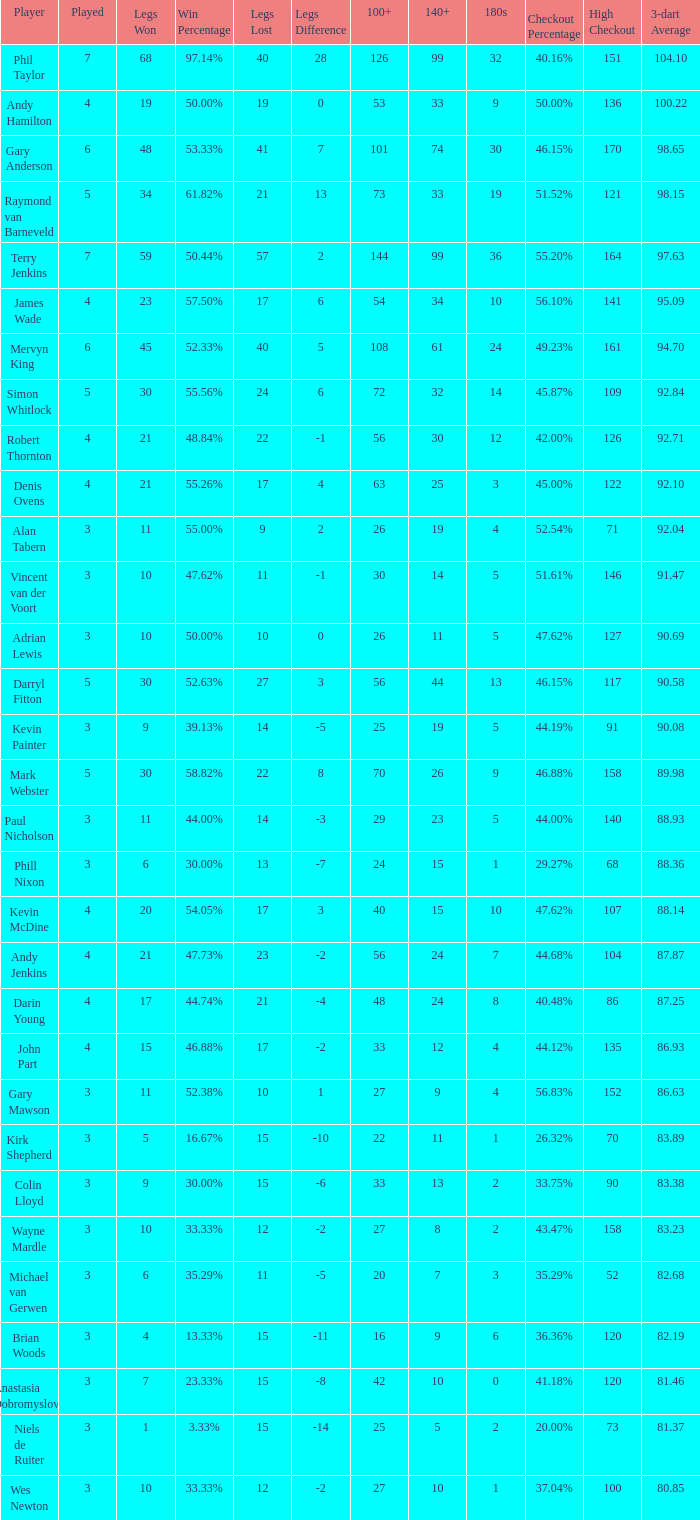Help me parse the entirety of this table. {'header': ['Player', 'Played', 'Legs Won', 'Win Percentage', 'Legs Lost', 'Legs Difference', '100+', '140+', '180s', 'Checkout Percentage', 'High Checkout', '3-dart Average'], 'rows': [['Phil Taylor', '7', '68', '97.14%', '40', '28', '126', '99', '32', '40.16%', '151', '104.10'], ['Andy Hamilton', '4', '19', '50.00%', '19', '0', '53', '33', '9', '50.00%', '136', '100.22'], ['Gary Anderson', '6', '48', '53.33%', '41', '7', '101', '74', '30', '46.15%', '170', '98.65'], ['Raymond van Barneveld', '5', '34', '61.82%', '21', '13', '73', '33', '19', '51.52%', '121', '98.15'], ['Terry Jenkins', '7', '59', '50.44%', '57', '2', '144', '99', '36', '55.20%', '164', '97.63'], ['James Wade', '4', '23', '57.50%', '17', '6', '54', '34', '10', '56.10%', '141', '95.09'], ['Mervyn King', '6', '45', '52.33%', '40', '5', '108', '61', '24', '49.23%', '161', '94.70'], ['Simon Whitlock', '5', '30', '55.56%', '24', '6', '72', '32', '14', '45.87%', '109', '92.84'], ['Robert Thornton', '4', '21', '48.84%', '22', '-1', '56', '30', '12', '42.00%', '126', '92.71'], ['Denis Ovens', '4', '21', '55.26%', '17', '4', '63', '25', '3', '45.00%', '122', '92.10'], ['Alan Tabern', '3', '11', '55.00%', '9', '2', '26', '19', '4', '52.54%', '71', '92.04'], ['Vincent van der Voort', '3', '10', '47.62%', '11', '-1', '30', '14', '5', '51.61%', '146', '91.47'], ['Adrian Lewis', '3', '10', '50.00%', '10', '0', '26', '11', '5', '47.62%', '127', '90.69'], ['Darryl Fitton', '5', '30', '52.63%', '27', '3', '56', '44', '13', '46.15%', '117', '90.58'], ['Kevin Painter', '3', '9', '39.13%', '14', '-5', '25', '19', '5', '44.19%', '91', '90.08'], ['Mark Webster', '5', '30', '58.82%', '22', '8', '70', '26', '9', '46.88%', '158', '89.98'], ['Paul Nicholson', '3', '11', '44.00%', '14', '-3', '29', '23', '5', '44.00%', '140', '88.93'], ['Phill Nixon', '3', '6', '30.00%', '13', '-7', '24', '15', '1', '29.27%', '68', '88.36'], ['Kevin McDine', '4', '20', '54.05%', '17', '3', '40', '15', '10', '47.62%', '107', '88.14'], ['Andy Jenkins', '4', '21', '47.73%', '23', '-2', '56', '24', '7', '44.68%', '104', '87.87'], ['Darin Young', '4', '17', '44.74%', '21', '-4', '48', '24', '8', '40.48%', '86', '87.25'], ['John Part', '4', '15', '46.88%', '17', '-2', '33', '12', '4', '44.12%', '135', '86.93'], ['Gary Mawson', '3', '11', '52.38%', '10', '1', '27', '9', '4', '56.83%', '152', '86.63'], ['Kirk Shepherd', '3', '5', '16.67%', '15', '-10', '22', '11', '1', '26.32%', '70', '83.89'], ['Colin Lloyd', '3', '9', '30.00%', '15', '-6', '33', '13', '2', '33.75%', '90', '83.38'], ['Wayne Mardle', '3', '10', '33.33%', '12', '-2', '27', '8', '2', '43.47%', '158', '83.23'], ['Michael van Gerwen', '3', '6', '35.29%', '11', '-5', '20', '7', '3', '35.29%', '52', '82.68'], ['Brian Woods', '3', '4', '13.33%', '15', '-11', '16', '9', '6', '36.36%', '120', '82.19'], ['Anastasia Dobromyslova', '3', '7', '23.33%', '15', '-8', '42', '10', '0', '41.18%', '120', '81.46'], ['Niels de Ruiter', '3', '1', '3.33%', '15', '-14', '25', '5', '2', '20.00%', '73', '81.37'], ['Wes Newton', '3', '10', '33.33%', '12', '-2', '27', '10', '1', '37.04%', '100', '80.85']]} What is the most legs lost of all? 57.0. 